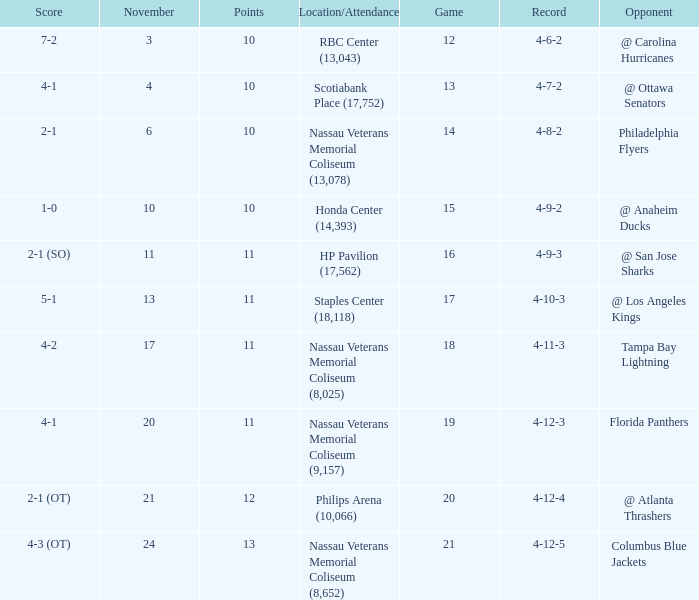What is the least amount of points? 10.0. 